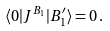<formula> <loc_0><loc_0><loc_500><loc_500>\langle 0 | J ^ { B _ { 1 } } | B ^ { \prime } _ { 1 } \rangle = 0 \, .</formula> 